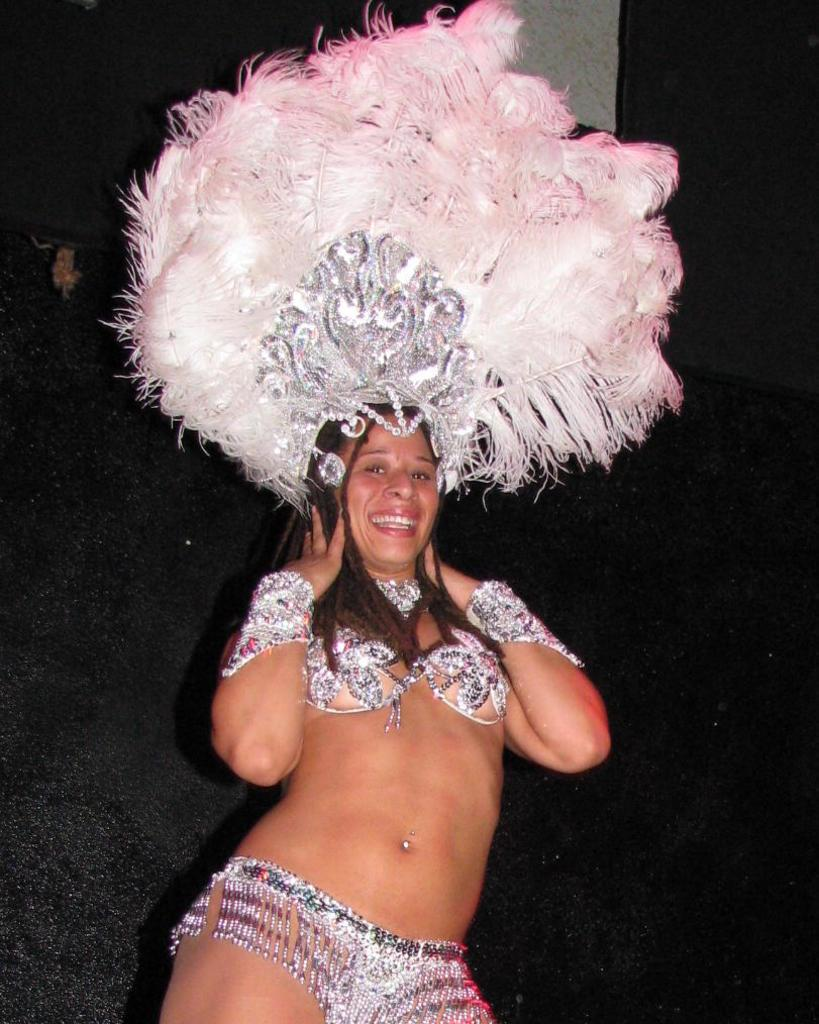What is the woman wearing in the image? The woman is wearing a different costume in the image. Can you describe the head-wear the woman is wearing? The woman is wearing a head-wear with white and pink color feathers. What is the color of the background in the image? The background of the image is black. What type of soap is the woman using in the image? There is no soap present in the image; the woman is wearing a costume with a head-wear. What is the woman doing with the eggnog in the image? There is no eggnog present in the image; the focus is on the woman's costume and head-wear. 